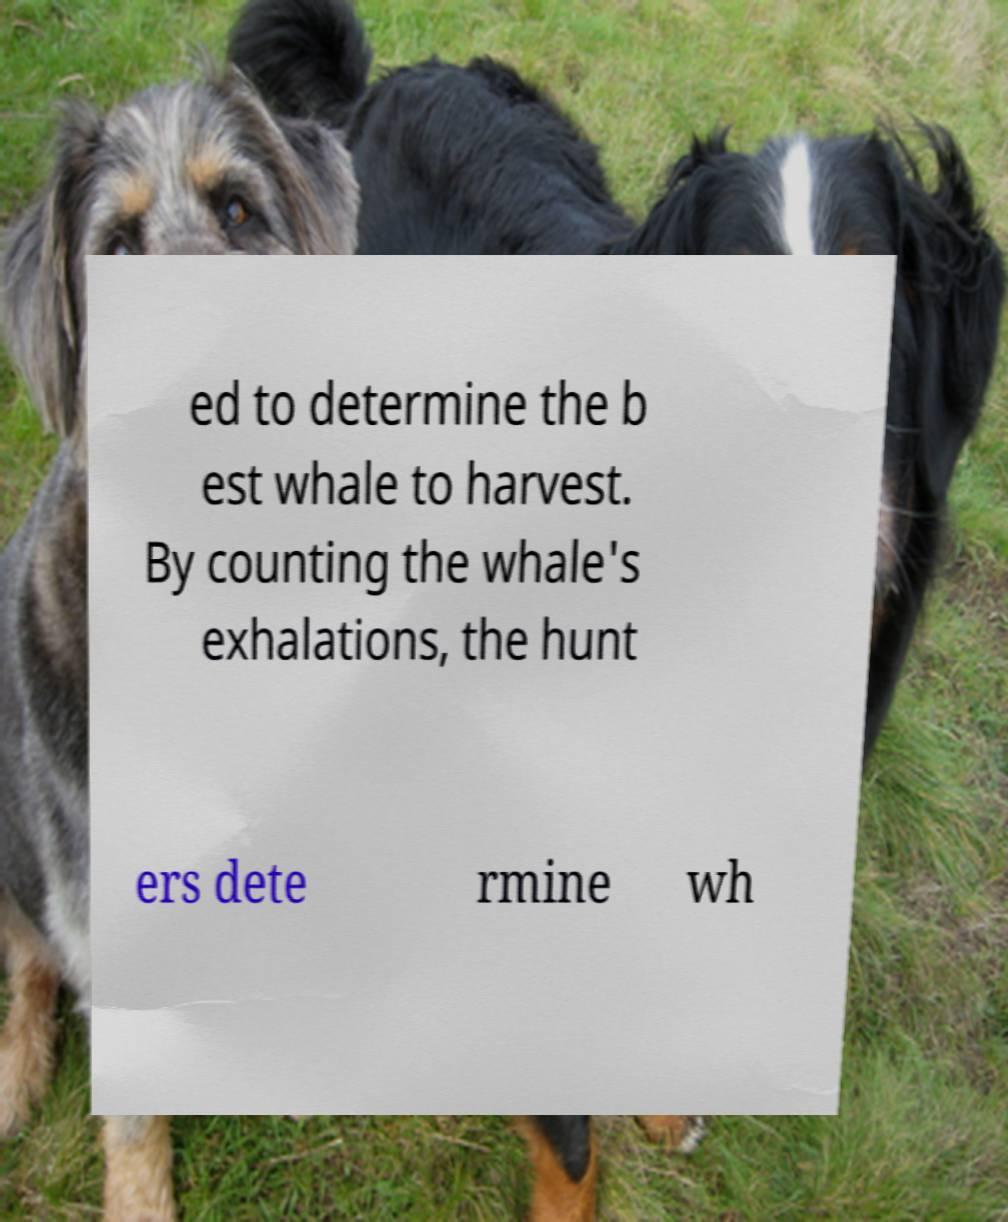There's text embedded in this image that I need extracted. Can you transcribe it verbatim? ed to determine the b est whale to harvest. By counting the whale's exhalations, the hunt ers dete rmine wh 